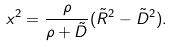Convert formula to latex. <formula><loc_0><loc_0><loc_500><loc_500>x ^ { 2 } = \frac { \rho } { \rho + \tilde { D } } ( \tilde { R } ^ { 2 } - \tilde { D } ^ { 2 } ) .</formula> 